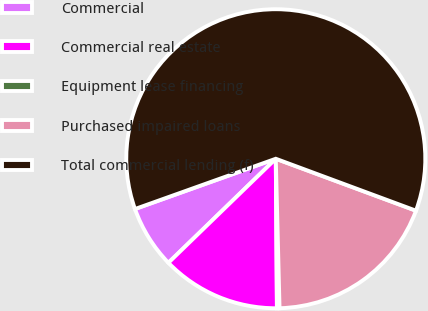<chart> <loc_0><loc_0><loc_500><loc_500><pie_chart><fcel>Commercial<fcel>Commercial real estate<fcel>Equipment lease financing<fcel>Purchased impaired loans<fcel>Total commercial lending (f)<nl><fcel>6.79%<fcel>12.87%<fcel>0.28%<fcel>18.95%<fcel>61.1%<nl></chart> 